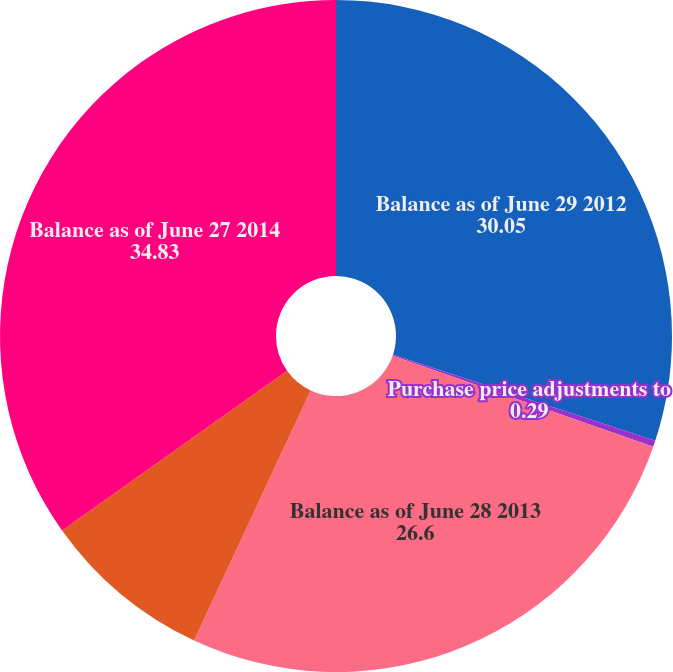Convert chart. <chart><loc_0><loc_0><loc_500><loc_500><pie_chart><fcel>Balance as of June 29 2012<fcel>Purchase price adjustments to<fcel>Balance as of June 28 2013<fcel>Goodwill recorded in<fcel>Balance as of June 27 2014<nl><fcel>30.05%<fcel>0.29%<fcel>26.6%<fcel>8.23%<fcel>34.83%<nl></chart> 